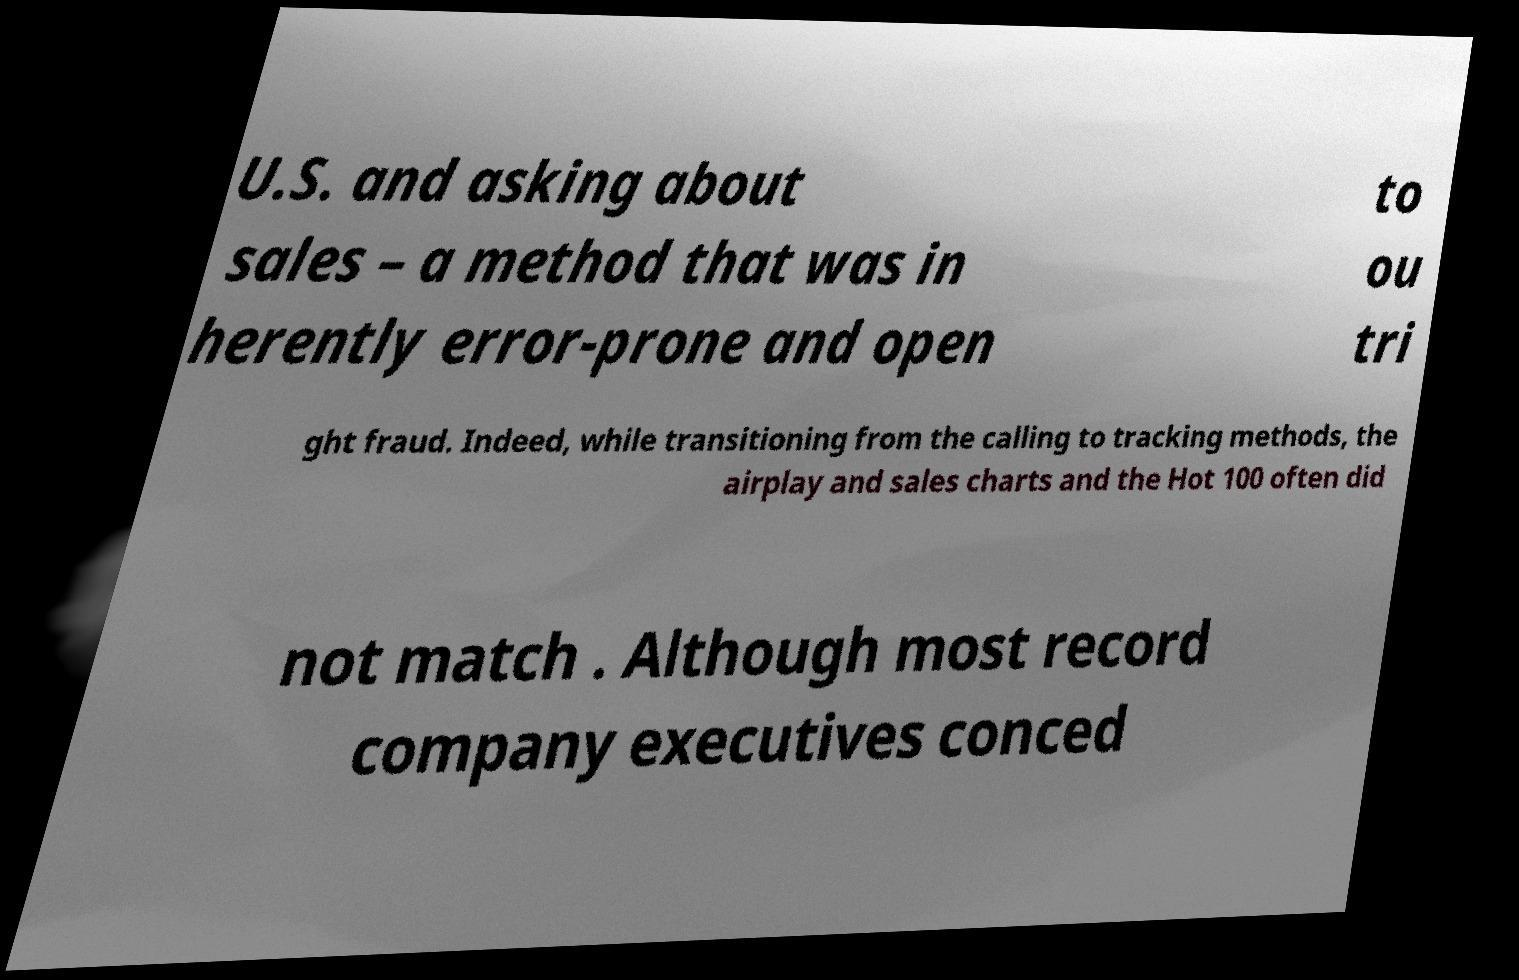There's text embedded in this image that I need extracted. Can you transcribe it verbatim? U.S. and asking about sales – a method that was in herently error-prone and open to ou tri ght fraud. Indeed, while transitioning from the calling to tracking methods, the airplay and sales charts and the Hot 100 often did not match . Although most record company executives conced 